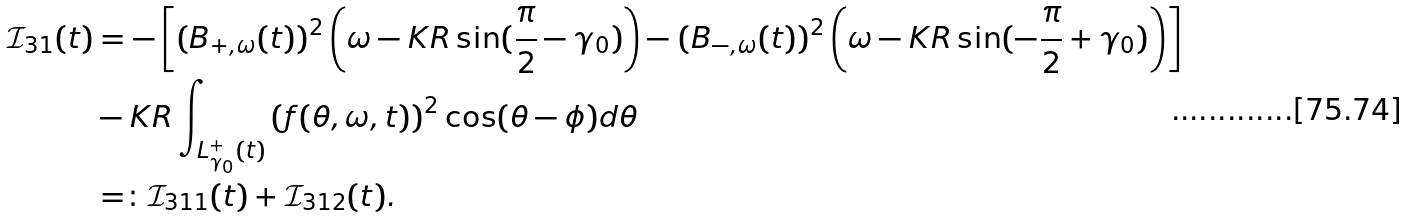<formula> <loc_0><loc_0><loc_500><loc_500>{ \mathcal { I } } _ { 3 1 } ( t ) & = - \left [ \left ( B _ { + , \omega } ( t ) \right ) ^ { 2 } \left ( \omega - K R \sin ( \frac { \pi } { 2 } - \gamma _ { 0 } ) \right ) - \left ( B _ { - , \omega } ( t ) \right ) ^ { 2 } \left ( \omega - K R \sin ( - \frac { \pi } { 2 } + \gamma _ { 0 } ) \right ) \right ] \\ & - K R \int _ { L ^ { + } _ { \gamma _ { 0 } } ( t ) } \left ( f ( \theta , \omega , t ) \right ) ^ { 2 } \cos ( \theta - \phi ) d \theta \\ & = \colon { \mathcal { I } } _ { 3 1 1 } ( t ) + { \mathcal { I } } _ { 3 1 2 } ( t ) .</formula> 